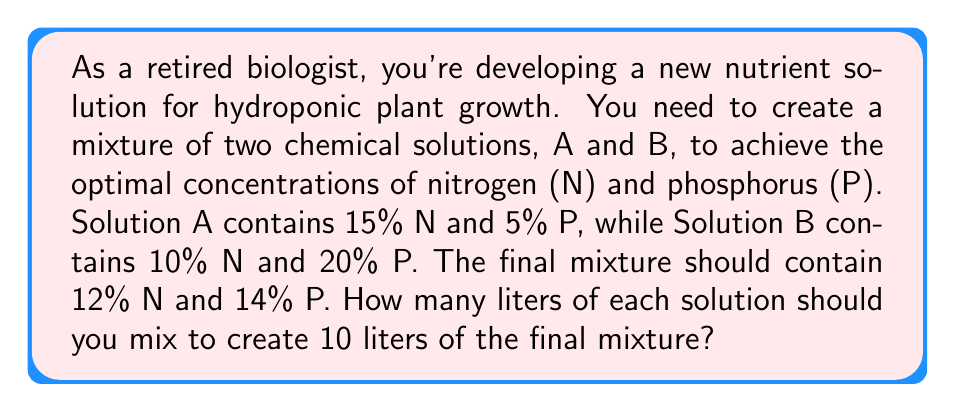Could you help me with this problem? Let's approach this step-by-step:

1) Let $x$ be the number of liters of Solution A and $y$ be the number of liters of Solution B.

2) The total volume equation:
   $$x + y = 10$$

3) For nitrogen (N), we can write:
   $$0.15x + 0.10y = 0.12(10)$$
   This is because 15% of x plus 10% of y should equal 12% of the total volume (10 liters).

4) Similarly for phosphorus (P):
   $$0.05x + 0.20y = 0.14(10)$$

5) Now we have a system of three equations:
   $$x + y = 10$$
   $$0.15x + 0.10y = 1.2$$
   $$0.05x + 0.20y = 1.4$$

6) From the first equation: $y = 10 - x$
   Substitute this into the second equation:
   $$0.15x + 0.10(10 - x) = 1.2$$
   $$0.15x + 1 - 0.10x = 1.2$$
   $$0.05x = 0.2$$
   $$x = 4$$

7) Since $x = 4$, and $x + y = 10$, we can deduce that $y = 6$.

8) To verify, let's check the third equation:
   $$0.05(4) + 0.20(6) = 0.2 + 1.2 = 1.4$$

Therefore, you should mix 4 liters of Solution A and 6 liters of Solution B.
Answer: 4 liters of Solution A, 6 liters of Solution B 